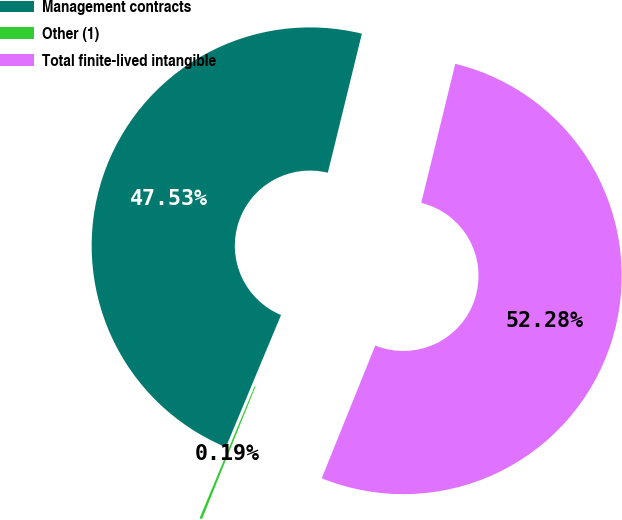<chart> <loc_0><loc_0><loc_500><loc_500><pie_chart><fcel>Management contracts<fcel>Other (1)<fcel>Total finite-lived intangible<nl><fcel>47.53%<fcel>0.19%<fcel>52.28%<nl></chart> 